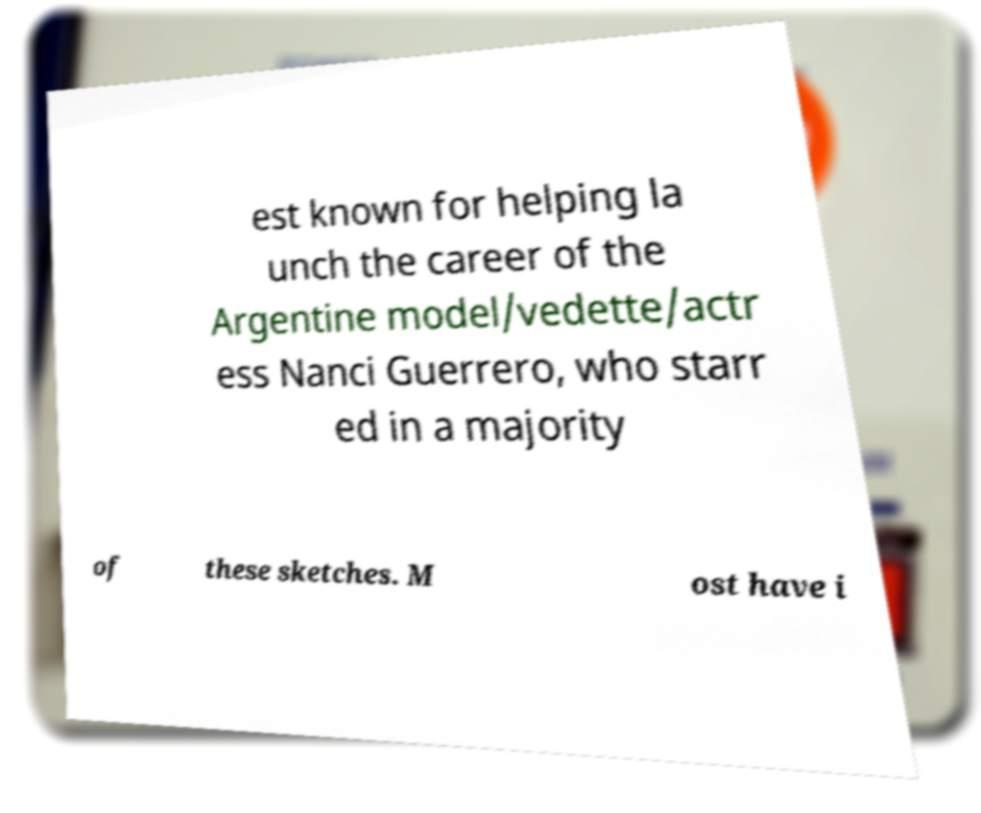What messages or text are displayed in this image? I need them in a readable, typed format. est known for helping la unch the career of the Argentine model/vedette/actr ess Nanci Guerrero, who starr ed in a majority of these sketches. M ost have i 